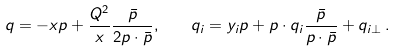Convert formula to latex. <formula><loc_0><loc_0><loc_500><loc_500>q = - x p + \frac { Q ^ { 2 } } { x } \frac { \bar { p } } { 2 p \cdot \bar { p } } , \quad q _ { i } = y _ { i } p + p \cdot q _ { i } \frac { \bar { p } } { p \cdot \bar { p } } + q _ { i \perp } \, .</formula> 